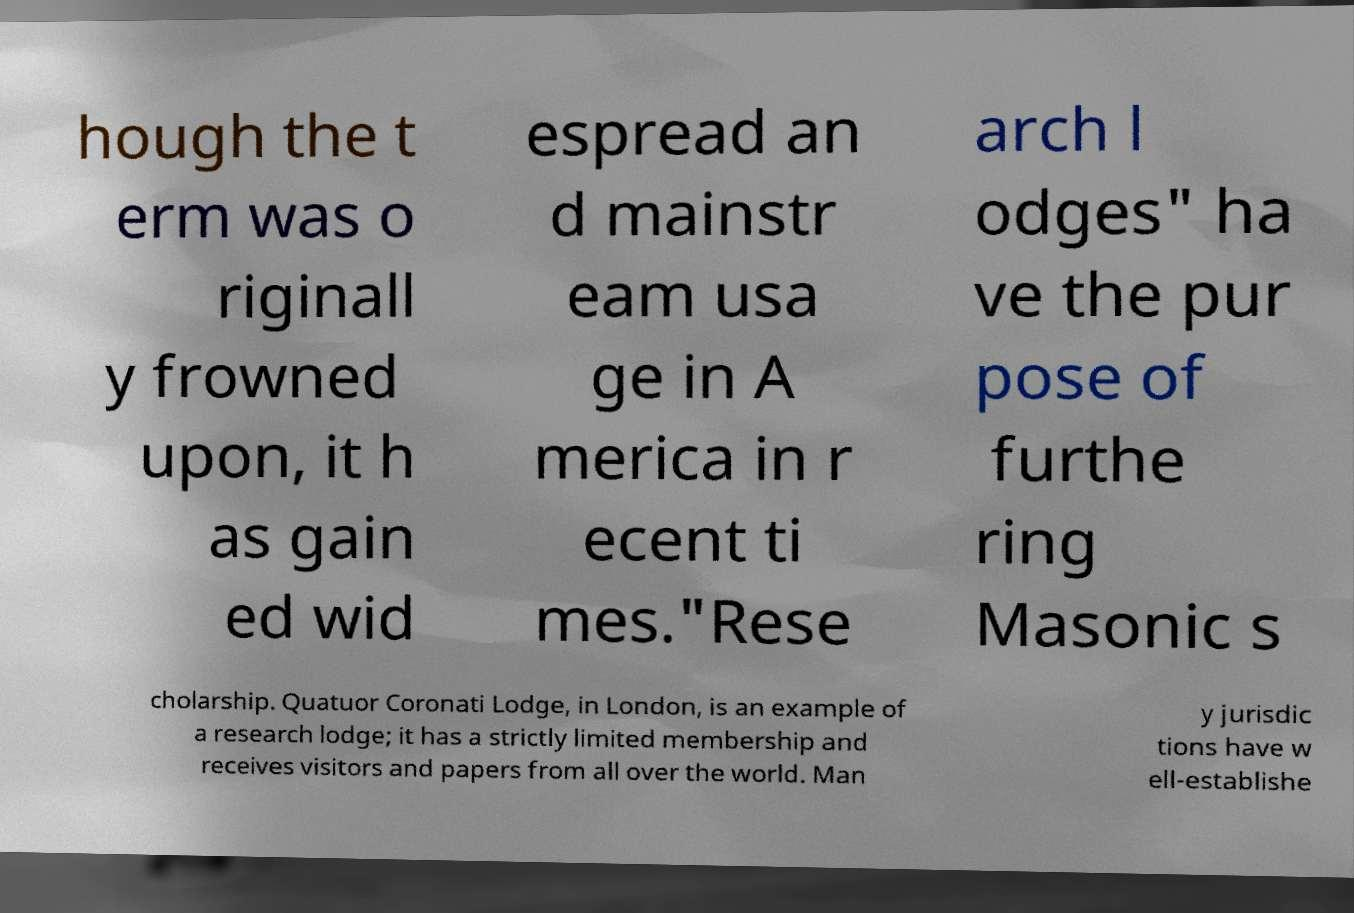Could you assist in decoding the text presented in this image and type it out clearly? hough the t erm was o riginall y frowned upon, it h as gain ed wid espread an d mainstr eam usa ge in A merica in r ecent ti mes."Rese arch l odges" ha ve the pur pose of furthe ring Masonic s cholarship. Quatuor Coronati Lodge, in London, is an example of a research lodge; it has a strictly limited membership and receives visitors and papers from all over the world. Man y jurisdic tions have w ell-establishe 